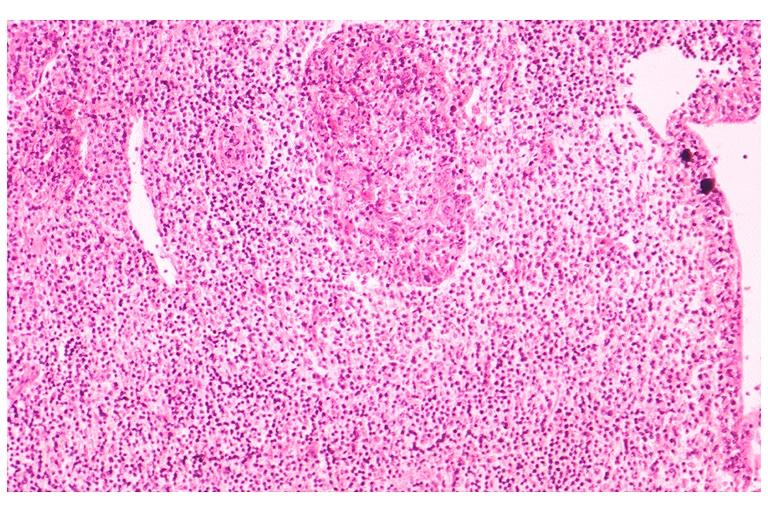what is present?
Answer the question using a single word or phrase. Oral 